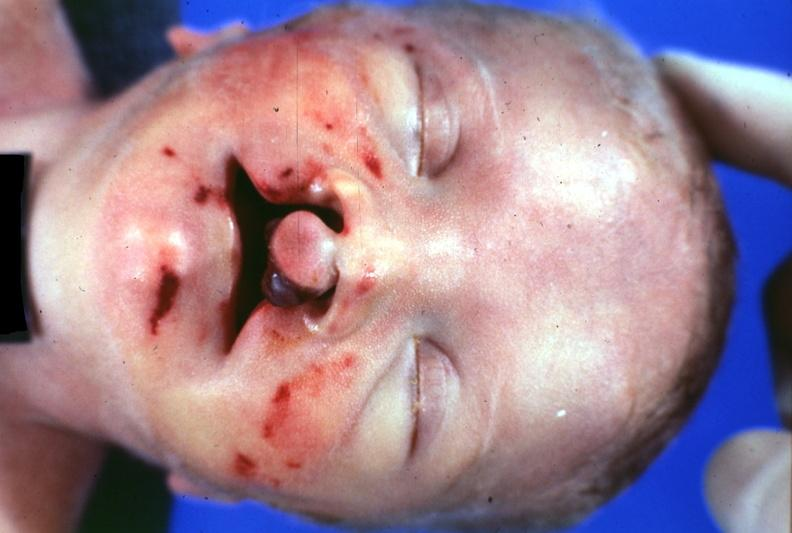does this image show close-up of head typical?
Answer the question using a single word or phrase. Yes 